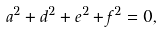<formula> <loc_0><loc_0><loc_500><loc_500>a ^ { 2 } + d ^ { 2 } + e ^ { 2 } + f ^ { 2 } = 0 ,</formula> 